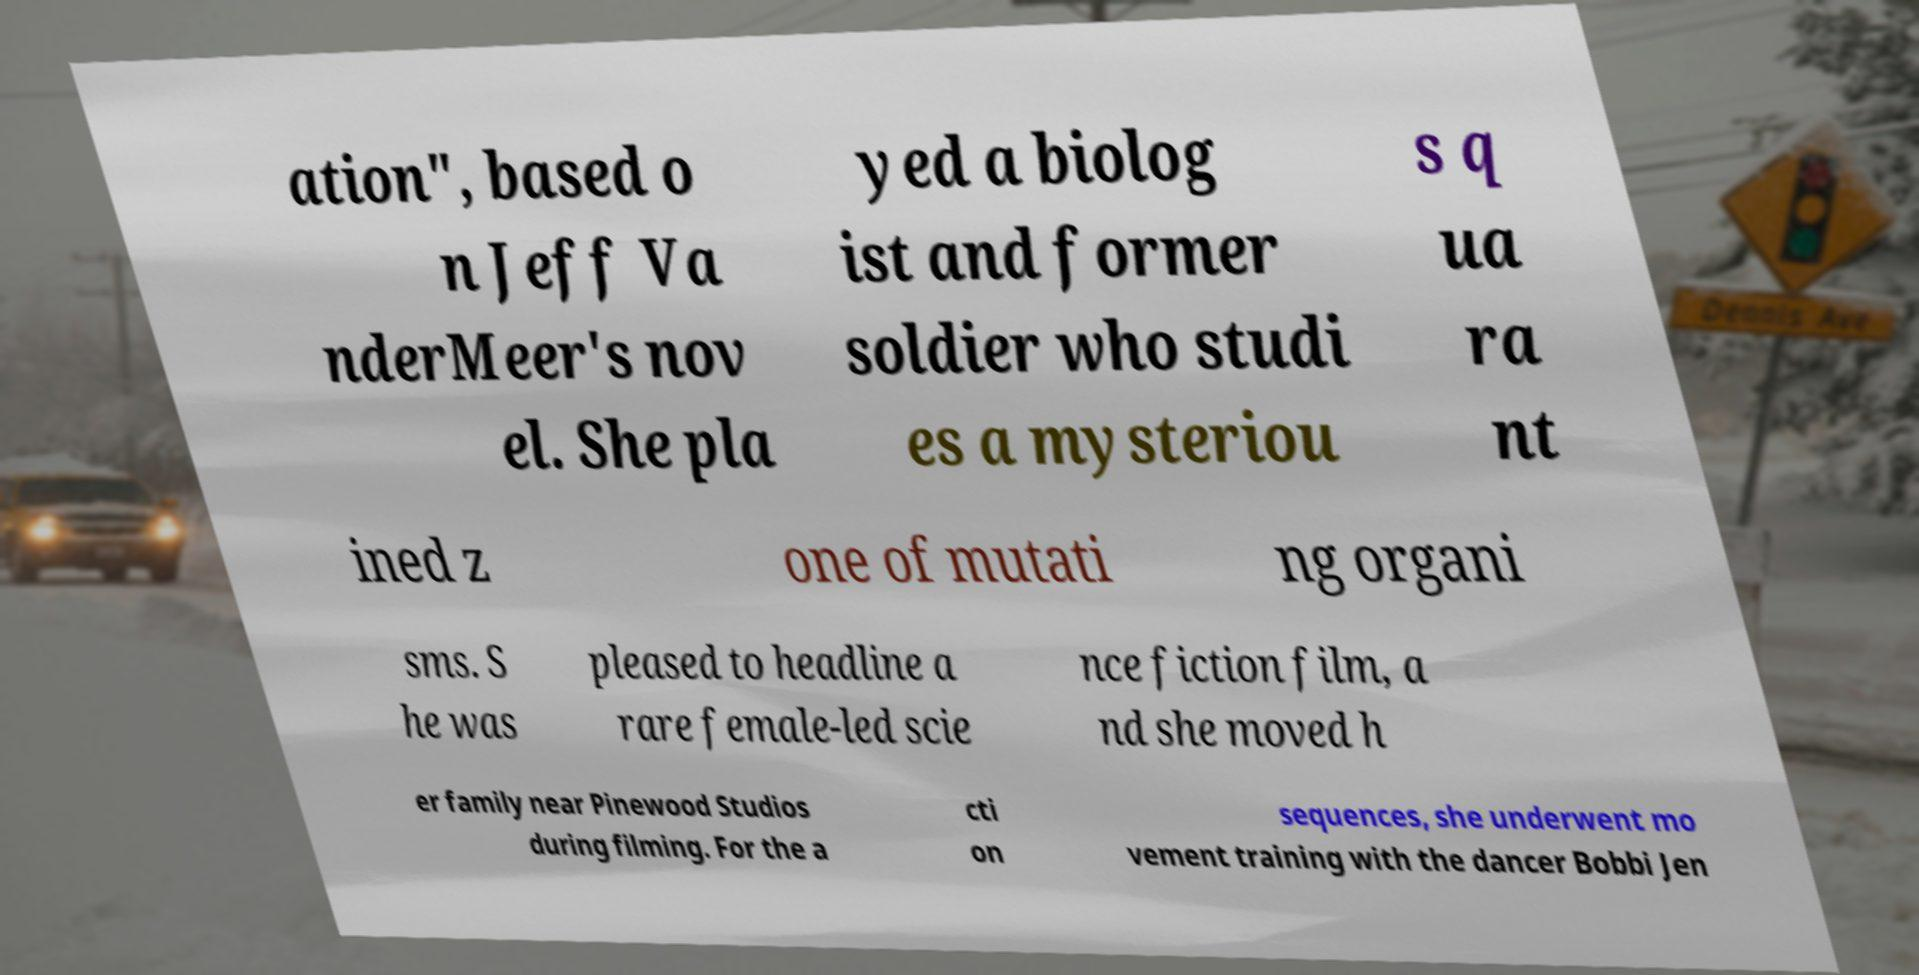For documentation purposes, I need the text within this image transcribed. Could you provide that? ation", based o n Jeff Va nderMeer's nov el. She pla yed a biolog ist and former soldier who studi es a mysteriou s q ua ra nt ined z one of mutati ng organi sms. S he was pleased to headline a rare female-led scie nce fiction film, a nd she moved h er family near Pinewood Studios during filming. For the a cti on sequences, she underwent mo vement training with the dancer Bobbi Jen 